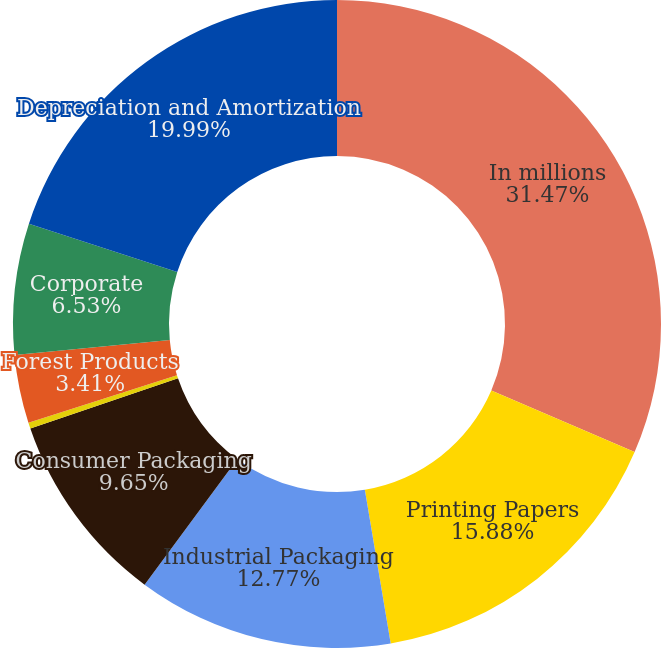Convert chart. <chart><loc_0><loc_0><loc_500><loc_500><pie_chart><fcel>In millions<fcel>Printing Papers<fcel>Industrial Packaging<fcel>Consumer Packaging<fcel>Distribution<fcel>Forest Products<fcel>Corporate<fcel>Depreciation and Amortization<nl><fcel>31.47%<fcel>15.88%<fcel>12.77%<fcel>9.65%<fcel>0.3%<fcel>3.41%<fcel>6.53%<fcel>19.99%<nl></chart> 